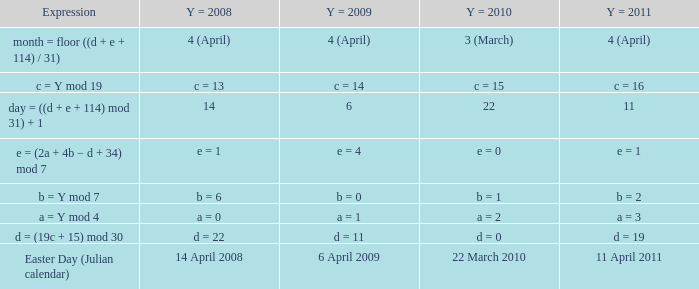What is the y = 2011 when the expression is month = floor ((d + e + 114) / 31)? 4 (April). 